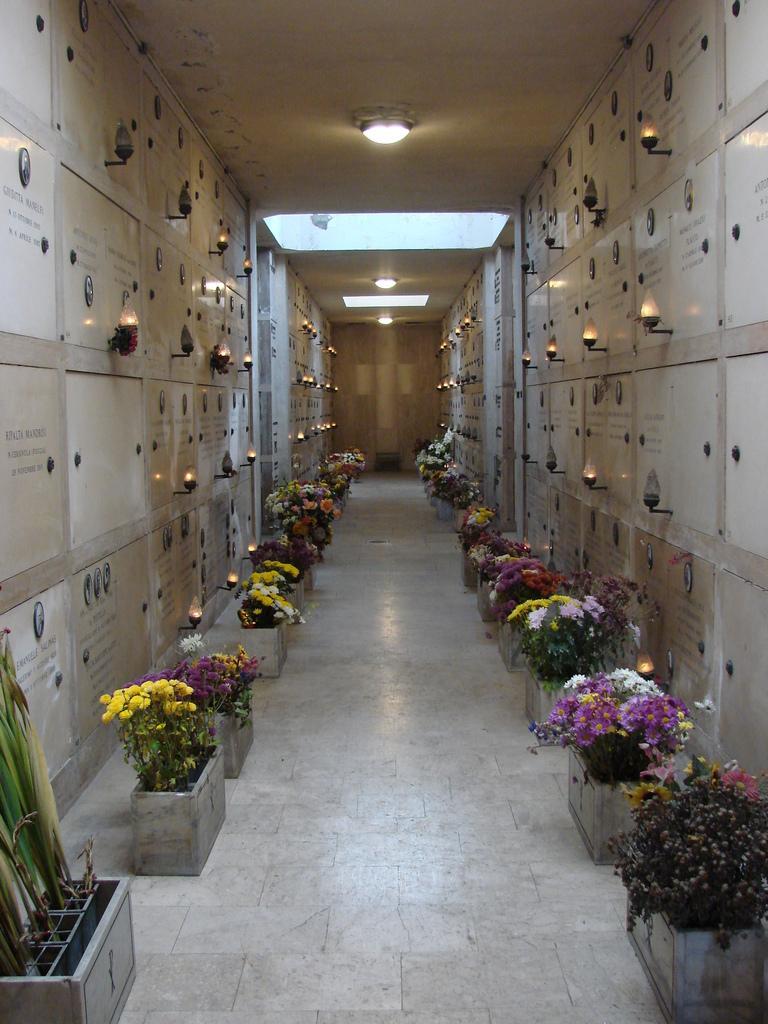In one or two sentences, can you explain what this image depicts? This image is clicked inside the building. It looks like a corridor. In which we can see many potted plants. On the left and right, there are small boards on the wall. And we can also see lights on the wall. At the top, there is a roof. At the bottom, there is a floor. 